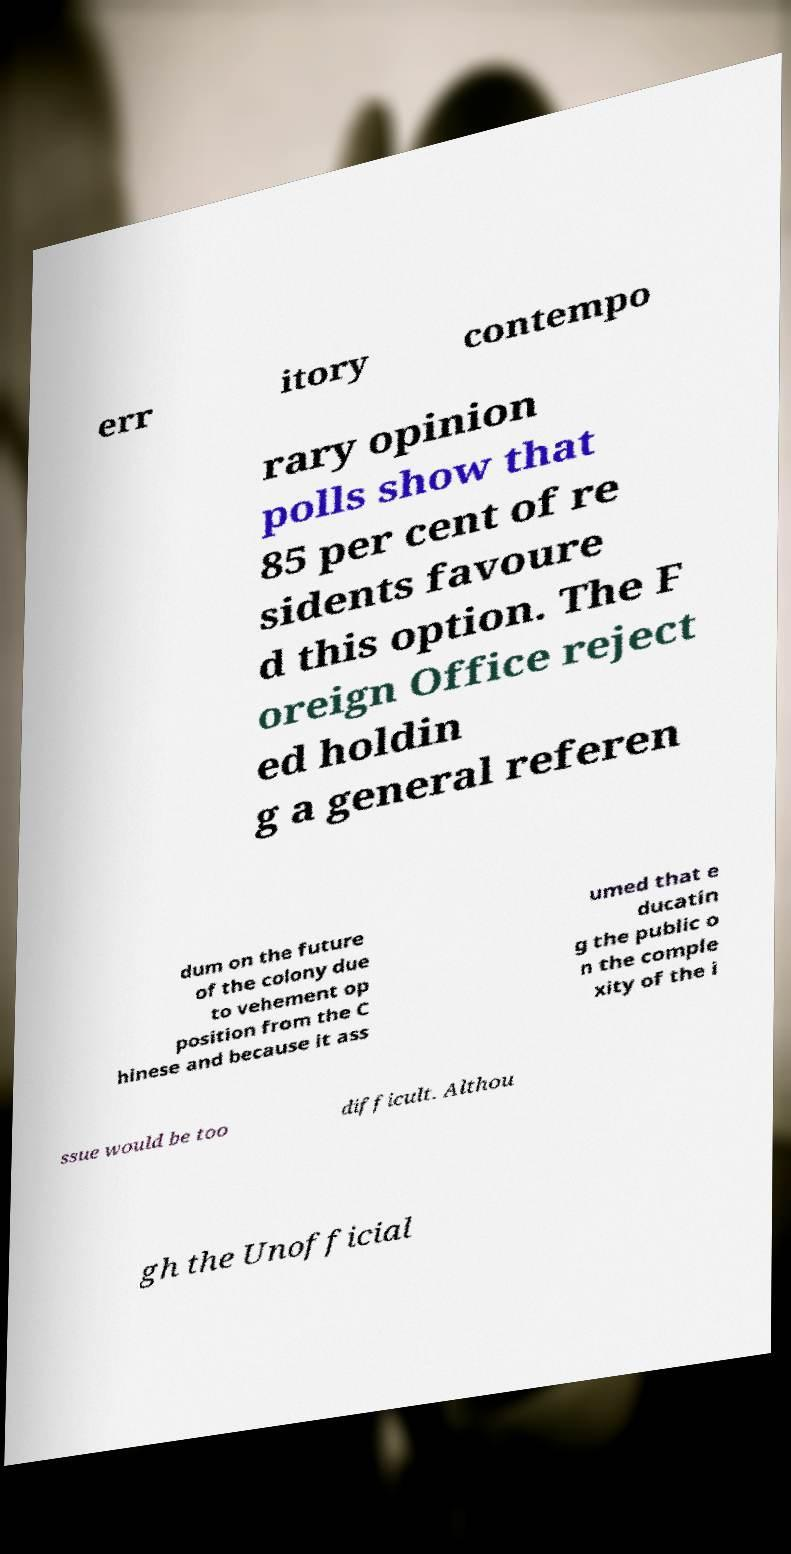Could you extract and type out the text from this image? err itory contempo rary opinion polls show that 85 per cent of re sidents favoure d this option. The F oreign Office reject ed holdin g a general referen dum on the future of the colony due to vehement op position from the C hinese and because it ass umed that e ducatin g the public o n the comple xity of the i ssue would be too difficult. Althou gh the Unofficial 